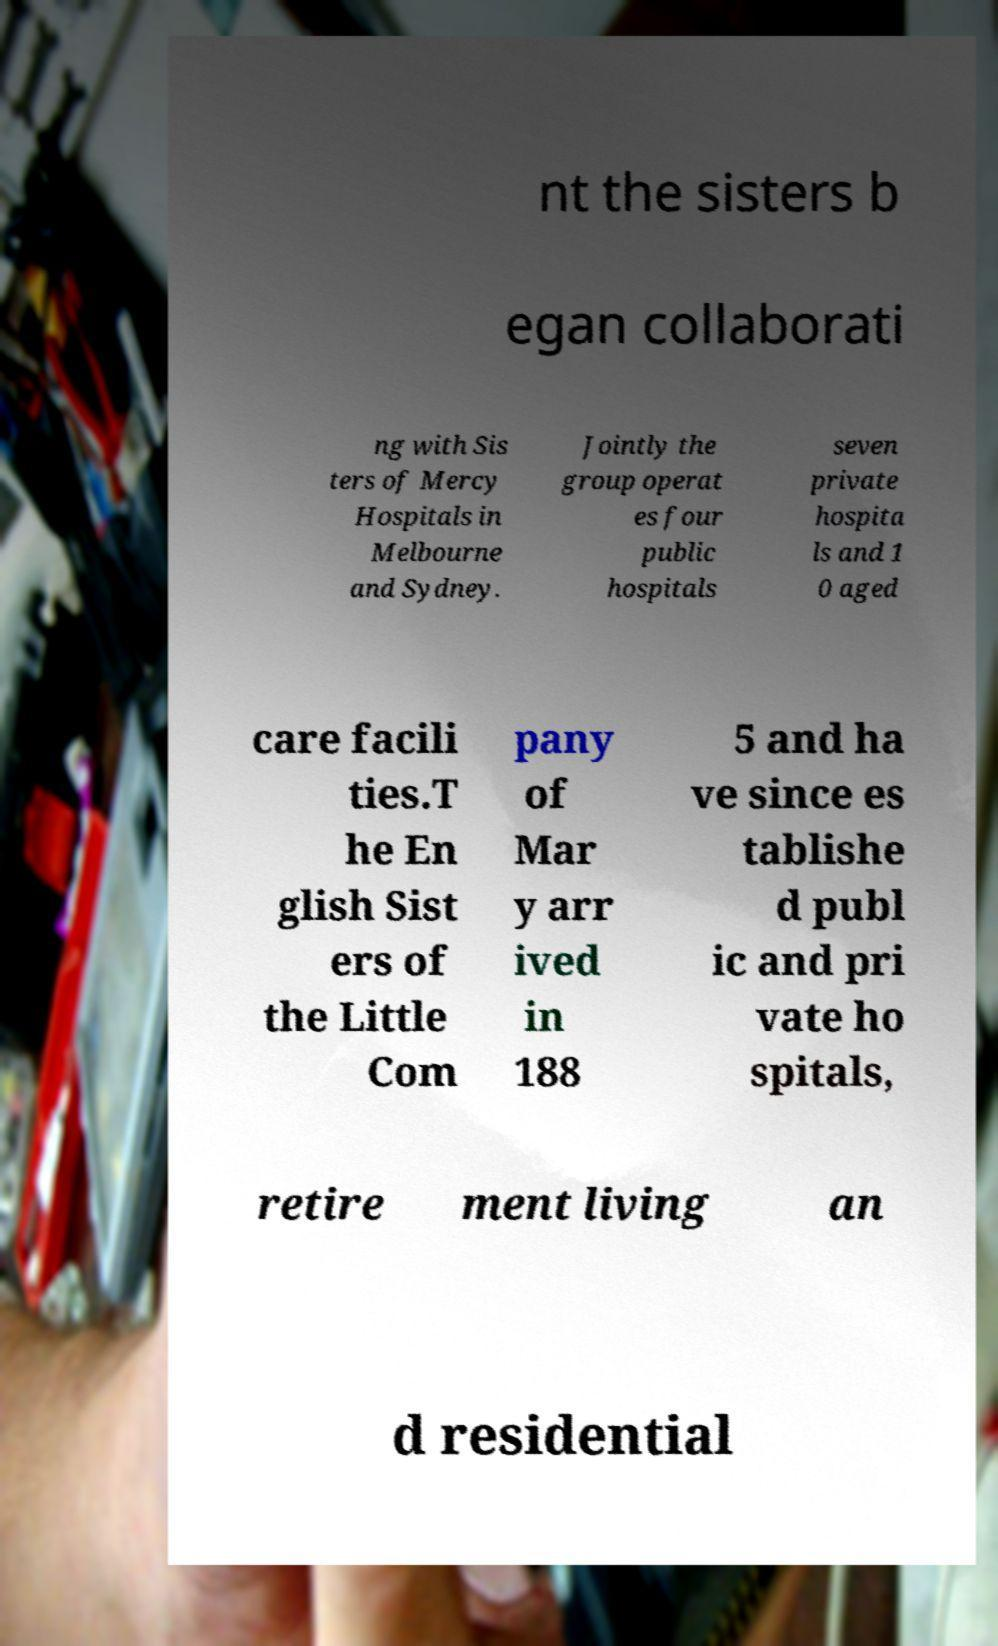There's text embedded in this image that I need extracted. Can you transcribe it verbatim? nt the sisters b egan collaborati ng with Sis ters of Mercy Hospitals in Melbourne and Sydney. Jointly the group operat es four public hospitals seven private hospita ls and 1 0 aged care facili ties.T he En glish Sist ers of the Little Com pany of Mar y arr ived in 188 5 and ha ve since es tablishe d publ ic and pri vate ho spitals, retire ment living an d residential 